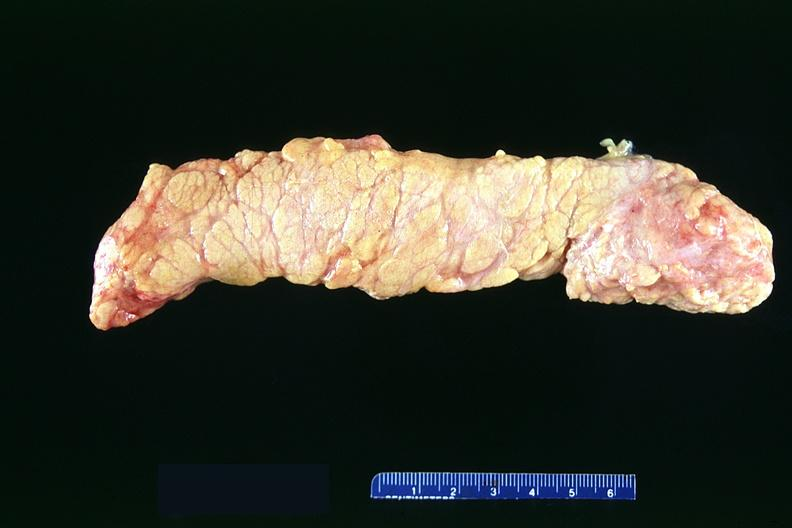does bone, clivus show normal pancreas?
Answer the question using a single word or phrase. No 